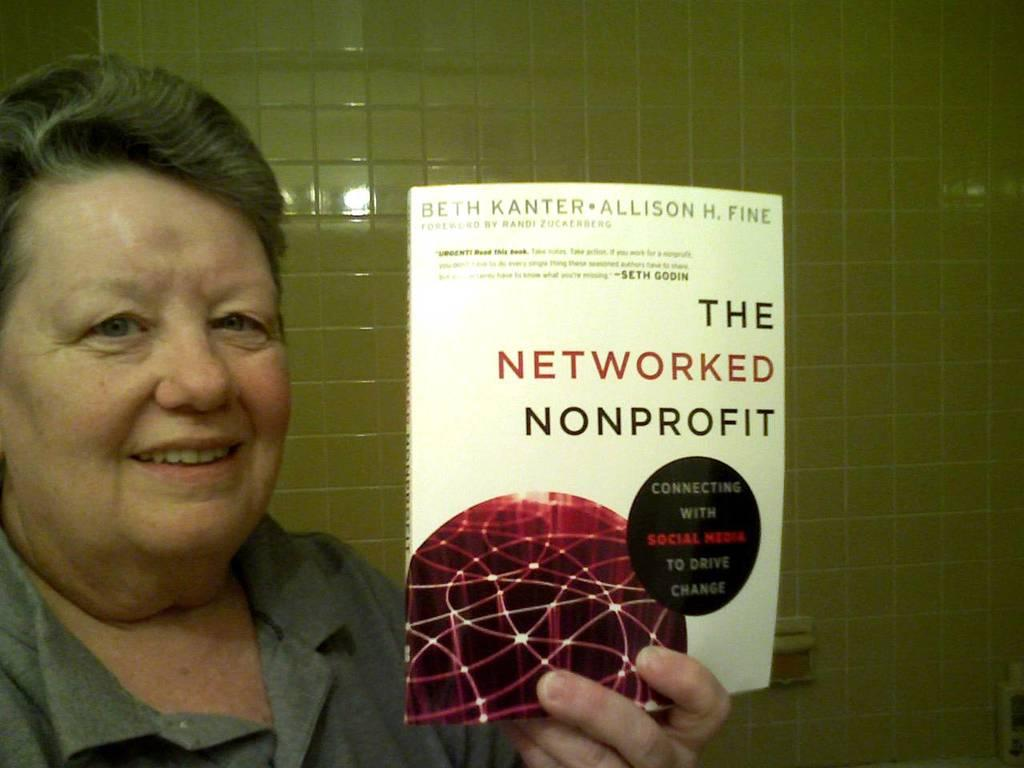What is the main subject in the foreground of the picture? There is a person in the foreground of the picture. What is the person holding in the picture? The person is holding a book. What can be seen in the background of the picture? There is a wall in the background of the picture. What type of cobweb can be seen on the wall in the image? There is no cobweb visible on the wall in the image. What is the taste of the thing the person is holding in the image? The person is holding a book, which does not have a taste. 